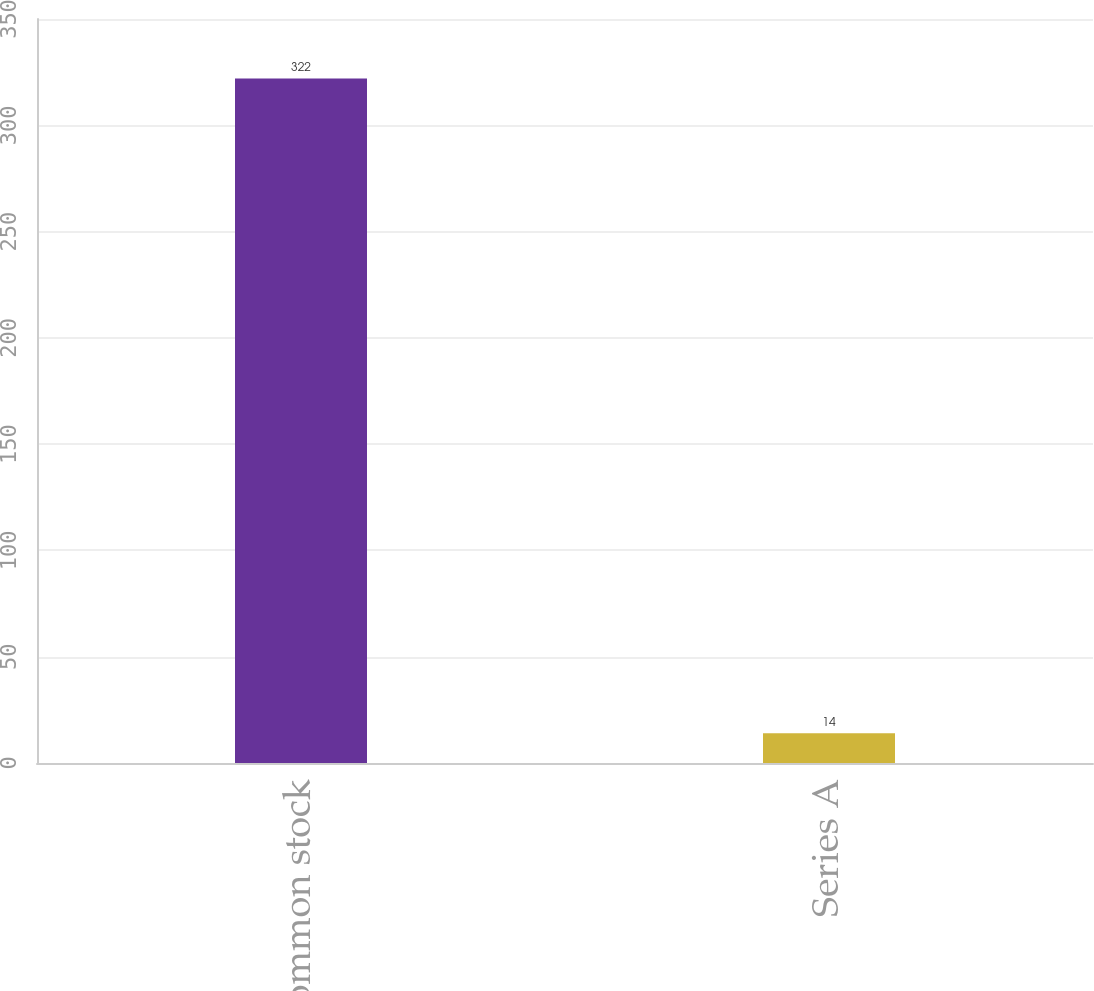Convert chart to OTSL. <chart><loc_0><loc_0><loc_500><loc_500><bar_chart><fcel>Common stock<fcel>Series A<nl><fcel>322<fcel>14<nl></chart> 